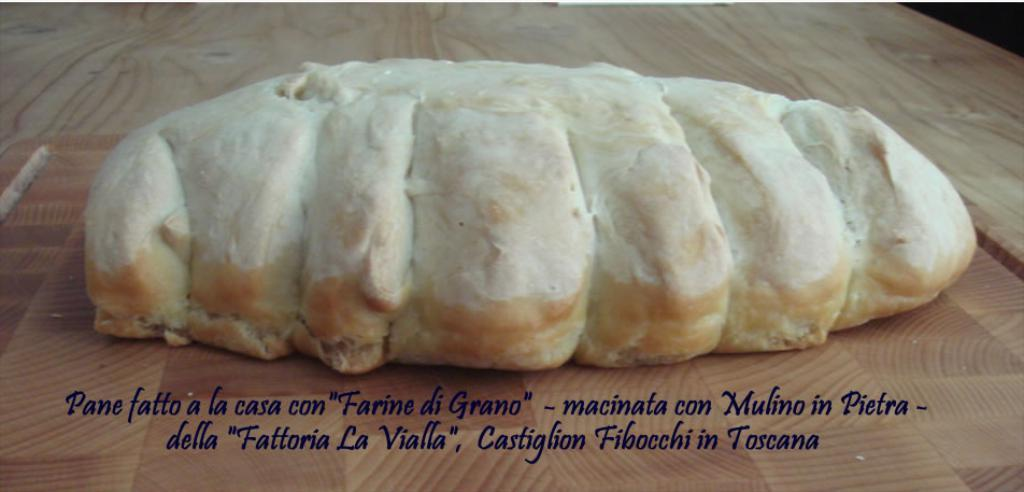What is the color of the powder on the pasty in the image? The powder on the pasty is white in color. What is the pasty placed on in the image? The pasty is on a wooden table. What type of text is present below the pasty? The text below the pasty is violet in color. How many marbles are used to measure the weight of the pasty in the image? There are no marbles present in the image, and the weight of the pasty is not mentioned. What type of ear is visible on the pasty in the image? There is no ear present on the pasty or in the image. 